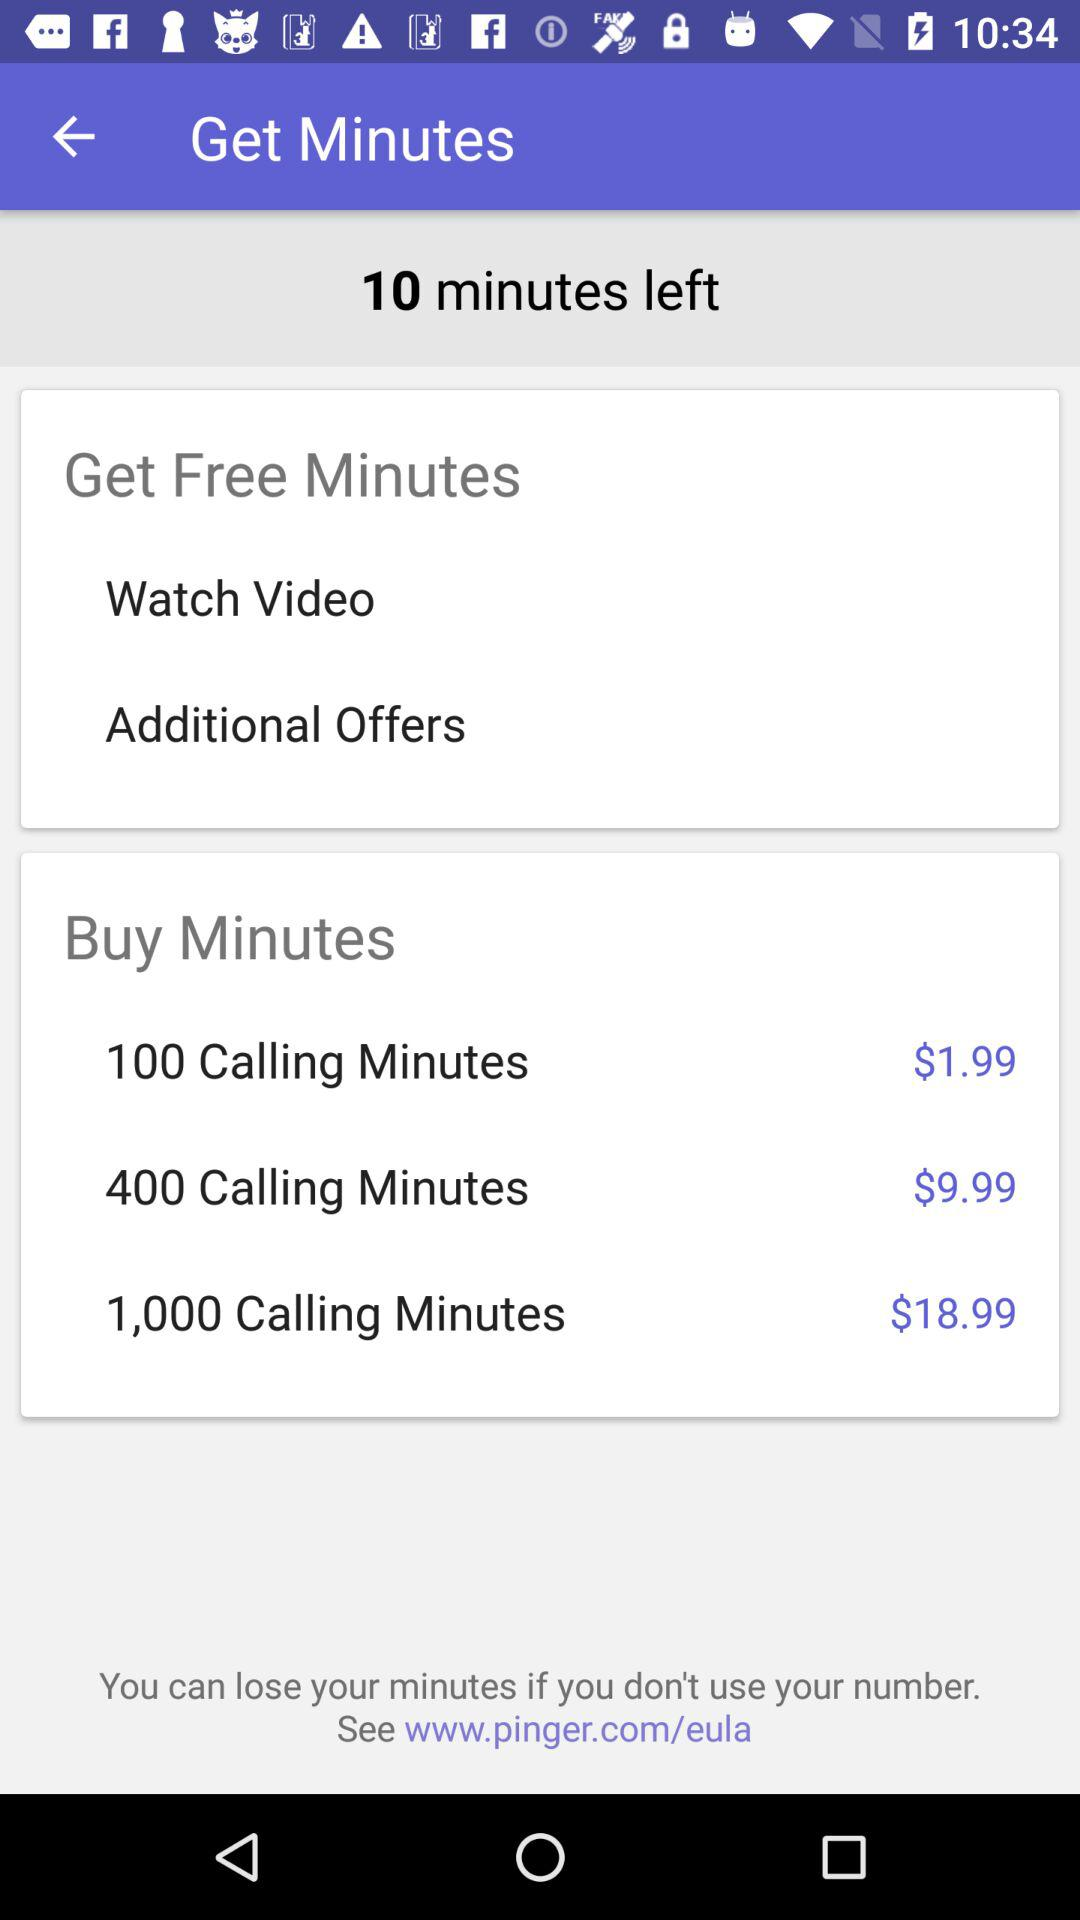How much more do I have to pay for 1,000 minutes than 400 minutes?
Answer the question using a single word or phrase. $9.00 